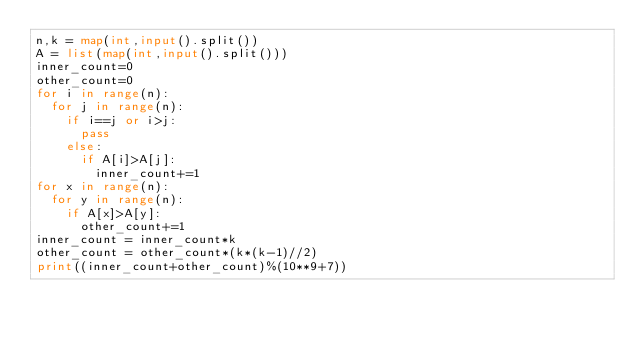<code> <loc_0><loc_0><loc_500><loc_500><_Python_>n,k = map(int,input().split())
A = list(map(int,input().split()))
inner_count=0
other_count=0
for i in range(n):
  for j in range(n):
    if i==j or i>j:
      pass
    else:
      if A[i]>A[j]:
        inner_count+=1
for x in range(n):
  for y in range(n):
    if A[x]>A[y]:
      other_count+=1
inner_count = inner_count*k
other_count = other_count*(k*(k-1)//2)
print((inner_count+other_count)%(10**9+7))</code> 